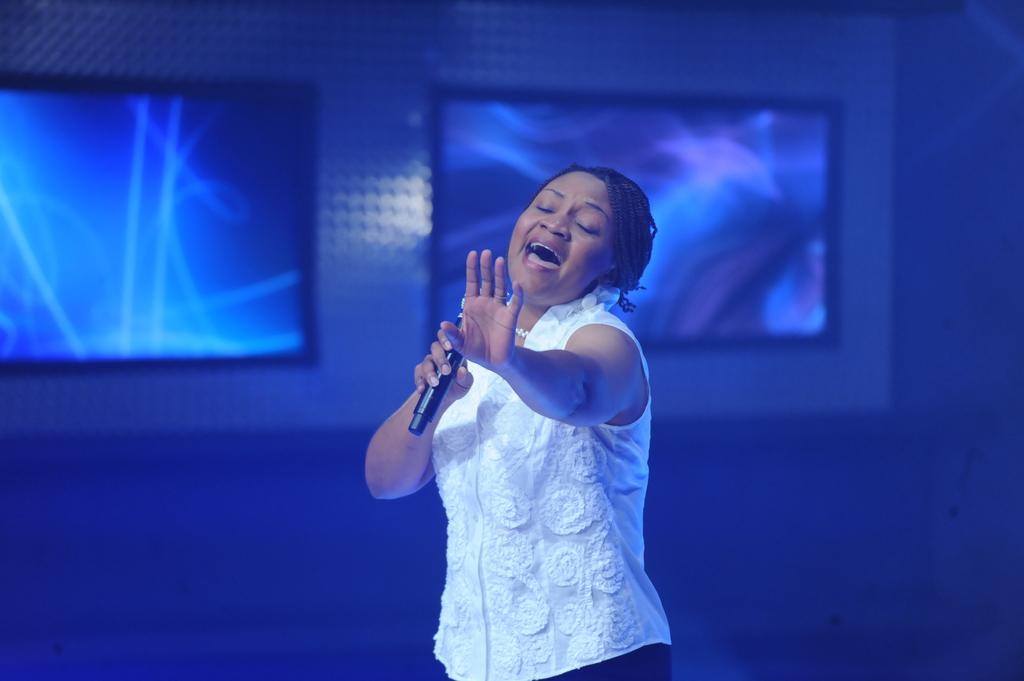Who is the main subject in the image? There is a woman in the image. What is the woman wearing? The woman is wearing a white top. What is the woman holding in the image? The woman is holding a microphone. What is the woman doing in the image? The woman is singing a song. What can be seen on the wall behind the woman? There are screens on the wall behind the woman. What type of bread can be seen on the table in the image? There is no bread present in the image; it features a woman singing with a microphone. 